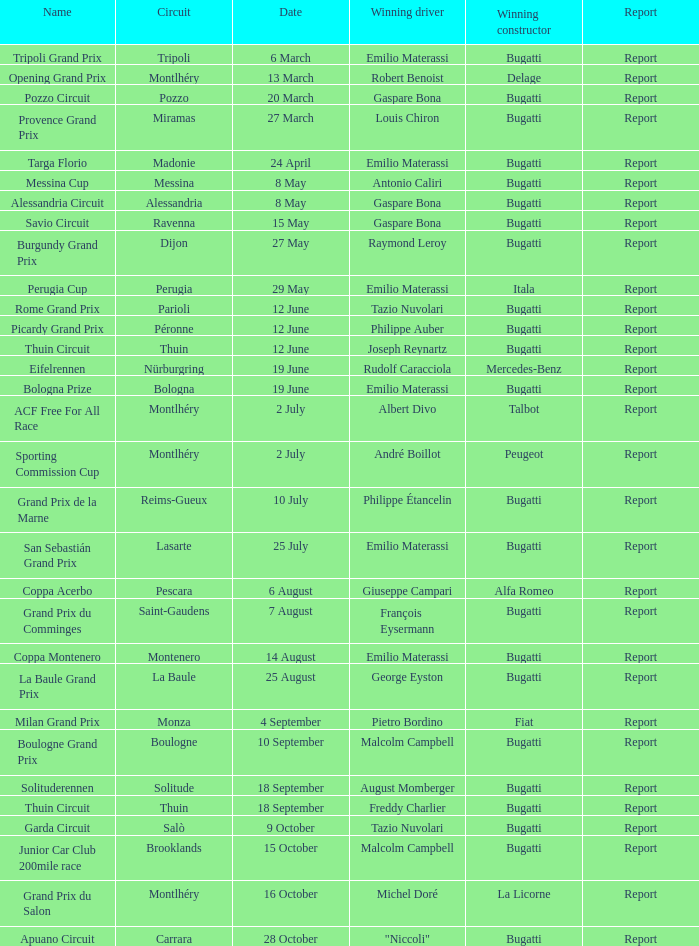Who was the winning constructor of the Grand Prix Du Salon ? La Licorne. 